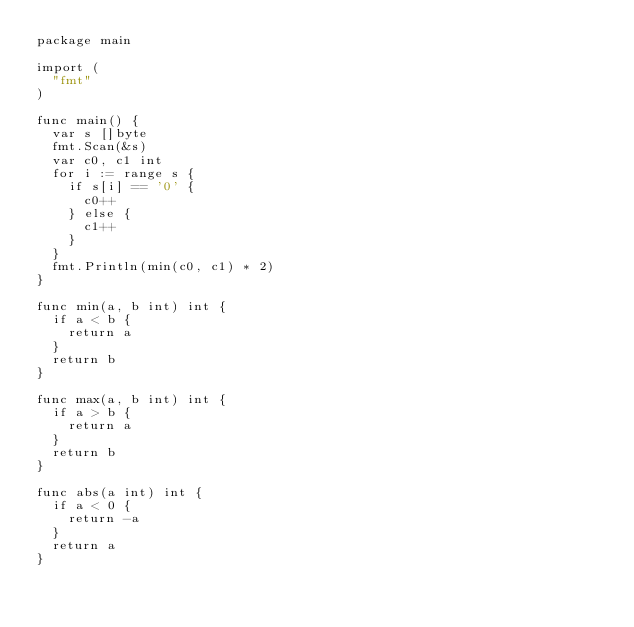<code> <loc_0><loc_0><loc_500><loc_500><_Go_>package main

import (
	"fmt"
)

func main() {
	var s []byte
	fmt.Scan(&s)
	var c0, c1 int
	for i := range s {
		if s[i] == '0' {
			c0++
		} else {
			c1++
		}
	}
	fmt.Println(min(c0, c1) * 2)
}

func min(a, b int) int {
	if a < b {
		return a
	}
	return b
}

func max(a, b int) int {
	if a > b {
		return a
	}
	return b
}

func abs(a int) int {
	if a < 0 {
		return -a
	}
	return a
}
</code> 